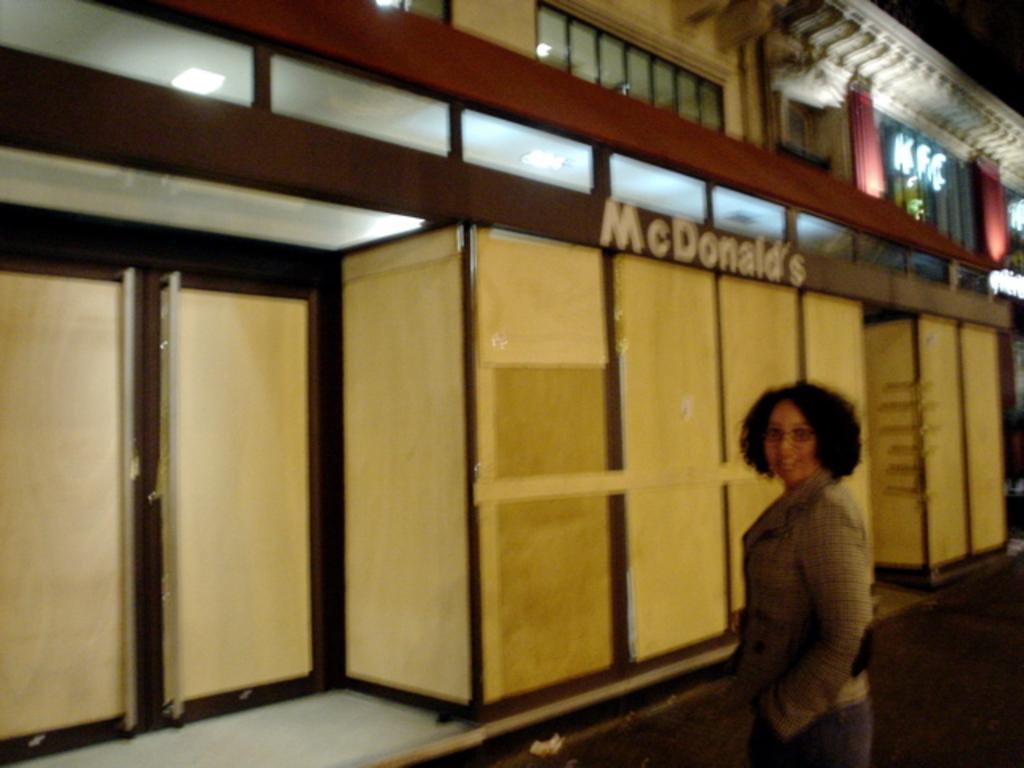In one or two sentences, can you explain what this image depicts? In this image we can see a woman and she wore spectacles. In the background we can see a building, boards, lights, and door. 